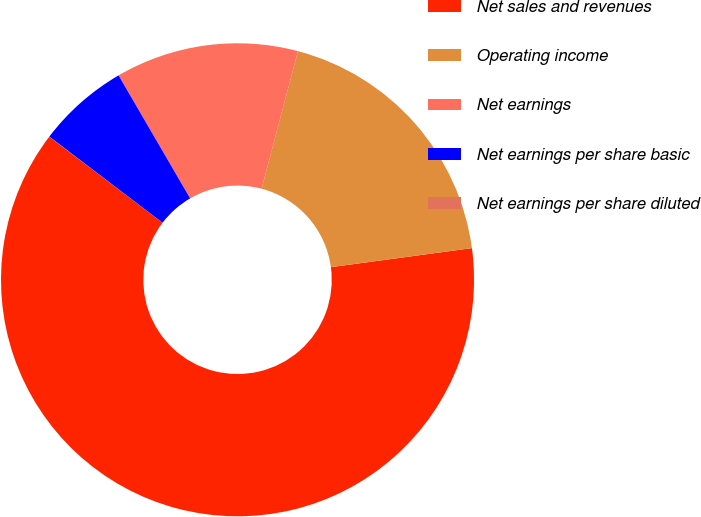Convert chart to OTSL. <chart><loc_0><loc_0><loc_500><loc_500><pie_chart><fcel>Net sales and revenues<fcel>Operating income<fcel>Net earnings<fcel>Net earnings per share basic<fcel>Net earnings per share diluted<nl><fcel>62.48%<fcel>18.75%<fcel>12.5%<fcel>6.26%<fcel>0.01%<nl></chart> 